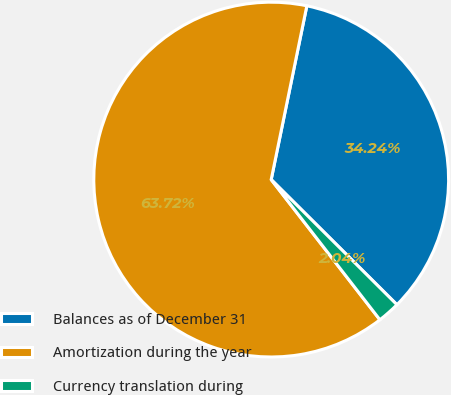<chart> <loc_0><loc_0><loc_500><loc_500><pie_chart><fcel>Balances as of December 31<fcel>Amortization during the year<fcel>Currency translation during<nl><fcel>34.24%<fcel>63.72%<fcel>2.04%<nl></chart> 